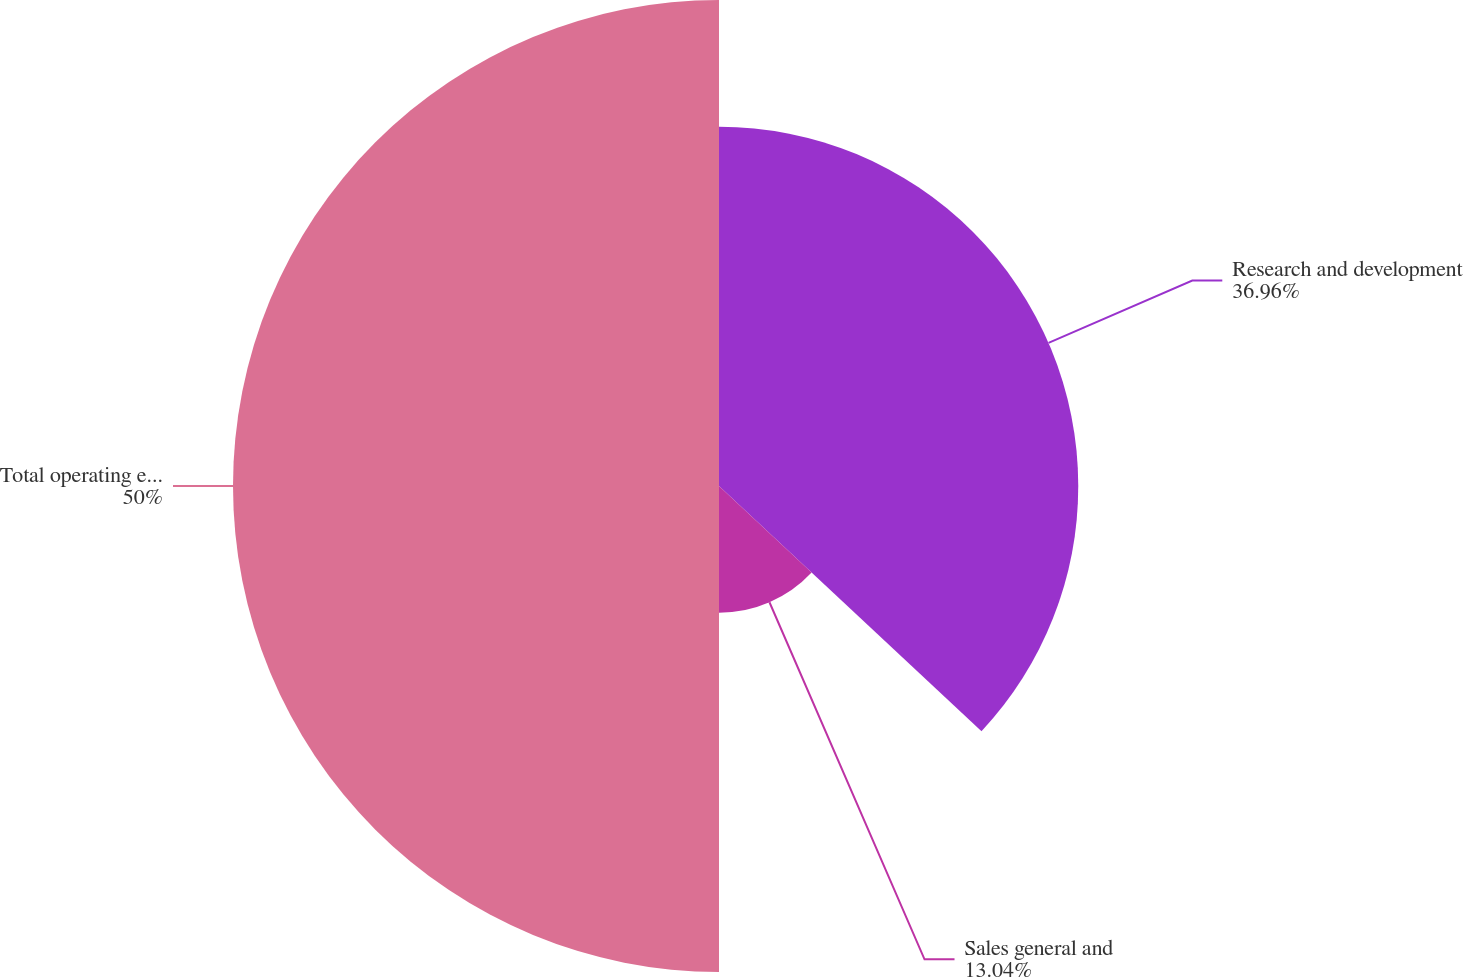Convert chart. <chart><loc_0><loc_0><loc_500><loc_500><pie_chart><fcel>Research and development<fcel>Sales general and<fcel>Total operating expenses<nl><fcel>36.96%<fcel>13.04%<fcel>50.0%<nl></chart> 